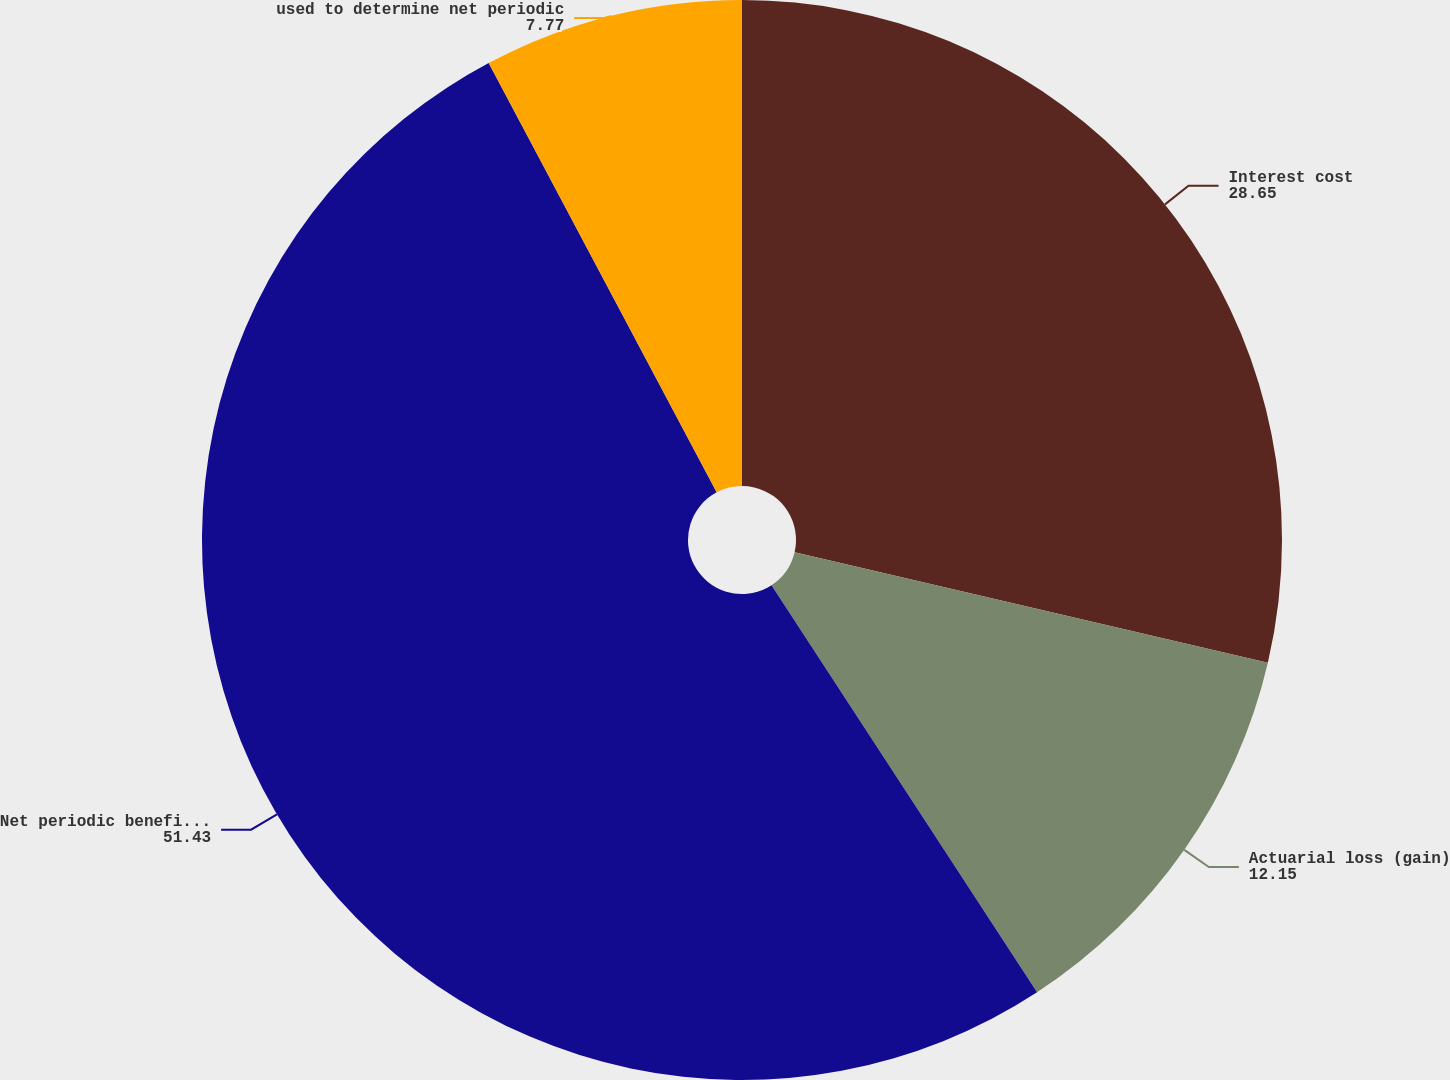Convert chart. <chart><loc_0><loc_0><loc_500><loc_500><pie_chart><fcel>Interest cost<fcel>Actuarial loss (gain)<fcel>Net periodic benefit cost<fcel>used to determine net periodic<nl><fcel>28.65%<fcel>12.15%<fcel>51.43%<fcel>7.77%<nl></chart> 